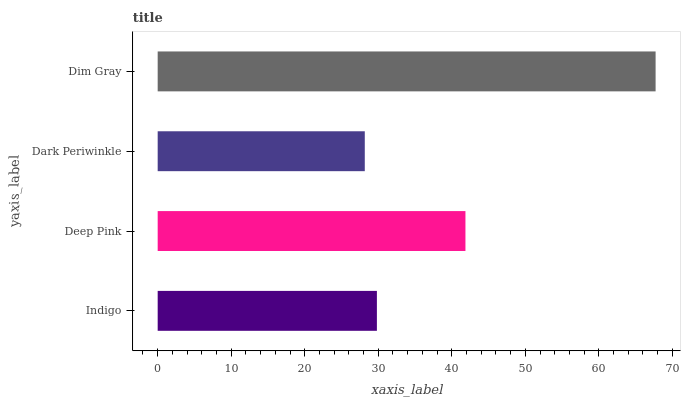Is Dark Periwinkle the minimum?
Answer yes or no. Yes. Is Dim Gray the maximum?
Answer yes or no. Yes. Is Deep Pink the minimum?
Answer yes or no. No. Is Deep Pink the maximum?
Answer yes or no. No. Is Deep Pink greater than Indigo?
Answer yes or no. Yes. Is Indigo less than Deep Pink?
Answer yes or no. Yes. Is Indigo greater than Deep Pink?
Answer yes or no. No. Is Deep Pink less than Indigo?
Answer yes or no. No. Is Deep Pink the high median?
Answer yes or no. Yes. Is Indigo the low median?
Answer yes or no. Yes. Is Indigo the high median?
Answer yes or no. No. Is Dark Periwinkle the low median?
Answer yes or no. No. 